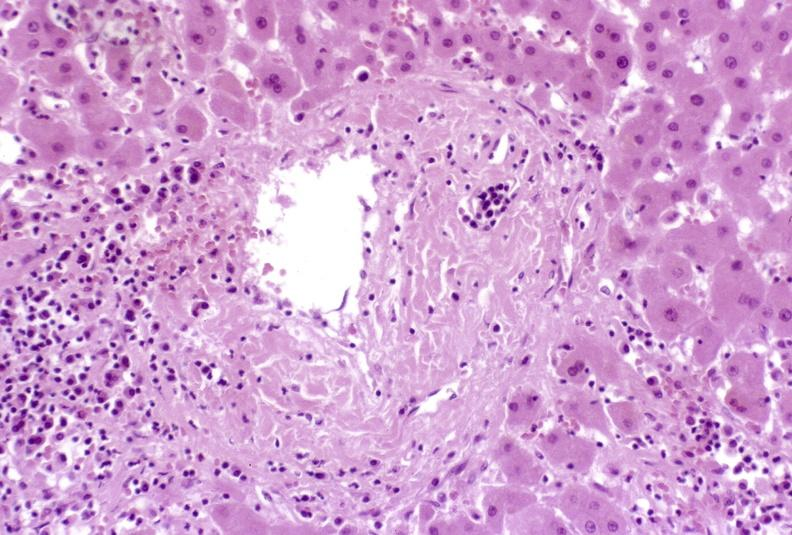s liver present?
Answer the question using a single word or phrase. Yes 